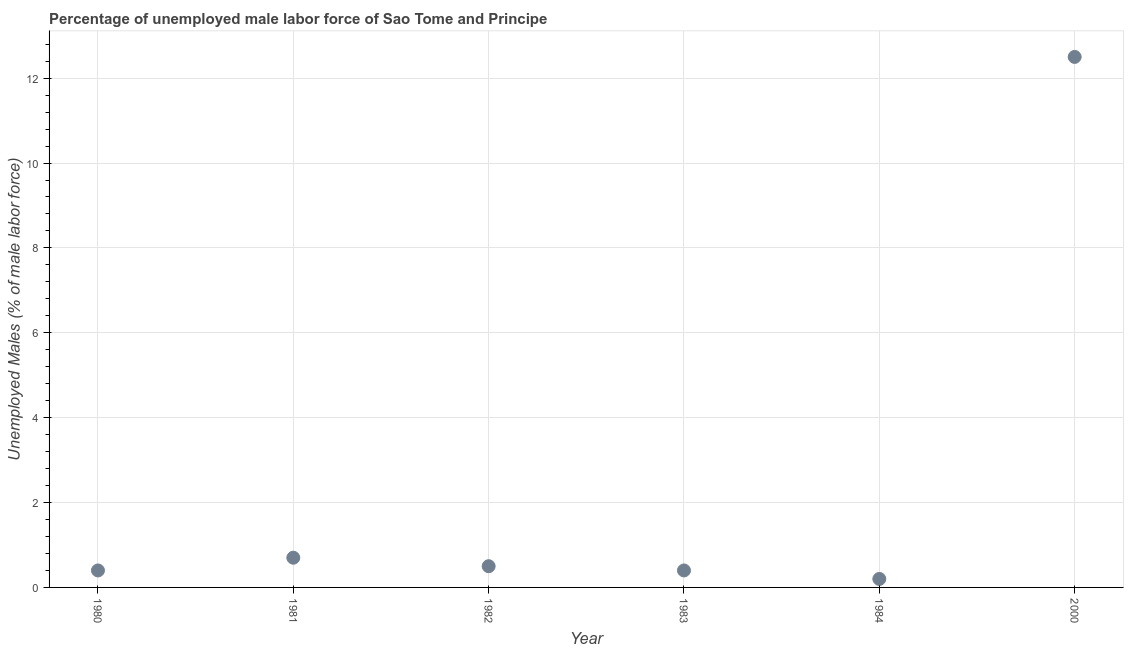What is the total unemployed male labour force in 1983?
Give a very brief answer. 0.4. Across all years, what is the maximum total unemployed male labour force?
Your answer should be very brief. 12.5. Across all years, what is the minimum total unemployed male labour force?
Your answer should be compact. 0.2. What is the sum of the total unemployed male labour force?
Make the answer very short. 14.7. What is the difference between the total unemployed male labour force in 1980 and 1981?
Offer a very short reply. -0.3. What is the average total unemployed male labour force per year?
Offer a terse response. 2.45. What is the median total unemployed male labour force?
Offer a very short reply. 0.45. Do a majority of the years between 1984 and 1981 (inclusive) have total unemployed male labour force greater than 10 %?
Make the answer very short. Yes. What is the ratio of the total unemployed male labour force in 1981 to that in 1983?
Provide a short and direct response. 1.75. Is the total unemployed male labour force in 1983 less than that in 1984?
Your response must be concise. No. Is the difference between the total unemployed male labour force in 1980 and 1983 greater than the difference between any two years?
Offer a terse response. No. What is the difference between the highest and the second highest total unemployed male labour force?
Provide a short and direct response. 11.8. What is the difference between the highest and the lowest total unemployed male labour force?
Offer a terse response. 12.3. Does the total unemployed male labour force monotonically increase over the years?
Make the answer very short. No. How many years are there in the graph?
Offer a very short reply. 6. What is the difference between two consecutive major ticks on the Y-axis?
Give a very brief answer. 2. Are the values on the major ticks of Y-axis written in scientific E-notation?
Give a very brief answer. No. What is the title of the graph?
Make the answer very short. Percentage of unemployed male labor force of Sao Tome and Principe. What is the label or title of the X-axis?
Your answer should be compact. Year. What is the label or title of the Y-axis?
Give a very brief answer. Unemployed Males (% of male labor force). What is the Unemployed Males (% of male labor force) in 1980?
Keep it short and to the point. 0.4. What is the Unemployed Males (% of male labor force) in 1981?
Give a very brief answer. 0.7. What is the Unemployed Males (% of male labor force) in 1982?
Give a very brief answer. 0.5. What is the Unemployed Males (% of male labor force) in 1983?
Your answer should be very brief. 0.4. What is the Unemployed Males (% of male labor force) in 1984?
Offer a terse response. 0.2. What is the difference between the Unemployed Males (% of male labor force) in 1980 and 1982?
Provide a short and direct response. -0.1. What is the difference between the Unemployed Males (% of male labor force) in 1980 and 1983?
Make the answer very short. 0. What is the difference between the Unemployed Males (% of male labor force) in 1980 and 1984?
Your answer should be compact. 0.2. What is the difference between the Unemployed Males (% of male labor force) in 1980 and 2000?
Your response must be concise. -12.1. What is the difference between the Unemployed Males (% of male labor force) in 1981 and 1983?
Provide a succinct answer. 0.3. What is the difference between the Unemployed Males (% of male labor force) in 1981 and 1984?
Provide a short and direct response. 0.5. What is the difference between the Unemployed Males (% of male labor force) in 1982 and 2000?
Offer a very short reply. -12. What is the ratio of the Unemployed Males (% of male labor force) in 1980 to that in 1981?
Your response must be concise. 0.57. What is the ratio of the Unemployed Males (% of male labor force) in 1980 to that in 1983?
Make the answer very short. 1. What is the ratio of the Unemployed Males (% of male labor force) in 1980 to that in 2000?
Give a very brief answer. 0.03. What is the ratio of the Unemployed Males (% of male labor force) in 1981 to that in 1982?
Your response must be concise. 1.4. What is the ratio of the Unemployed Males (% of male labor force) in 1981 to that in 1983?
Ensure brevity in your answer.  1.75. What is the ratio of the Unemployed Males (% of male labor force) in 1981 to that in 2000?
Ensure brevity in your answer.  0.06. What is the ratio of the Unemployed Males (% of male labor force) in 1982 to that in 1983?
Provide a short and direct response. 1.25. What is the ratio of the Unemployed Males (% of male labor force) in 1982 to that in 1984?
Offer a very short reply. 2.5. What is the ratio of the Unemployed Males (% of male labor force) in 1983 to that in 1984?
Your answer should be compact. 2. What is the ratio of the Unemployed Males (% of male labor force) in 1983 to that in 2000?
Offer a terse response. 0.03. What is the ratio of the Unemployed Males (% of male labor force) in 1984 to that in 2000?
Your answer should be compact. 0.02. 